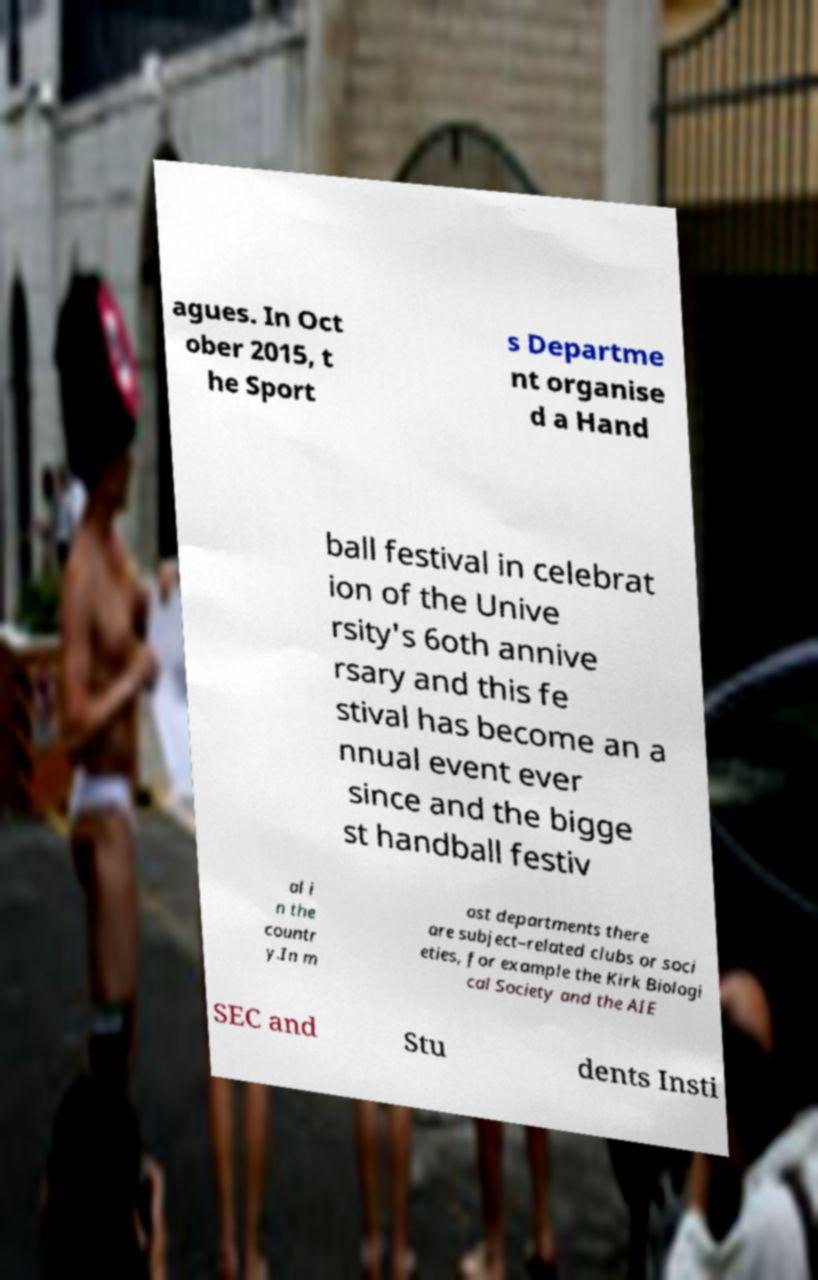Can you read and provide the text displayed in the image?This photo seems to have some interesting text. Can you extract and type it out for me? agues. In Oct ober 2015, t he Sport s Departme nt organise d a Hand ball festival in celebrat ion of the Unive rsity's 6oth annive rsary and this fe stival has become an a nnual event ever since and the bigge st handball festiv al i n the countr y.In m ost departments there are subject–related clubs or soci eties, for example the Kirk Biologi cal Society and the AIE SEC and Stu dents Insti 